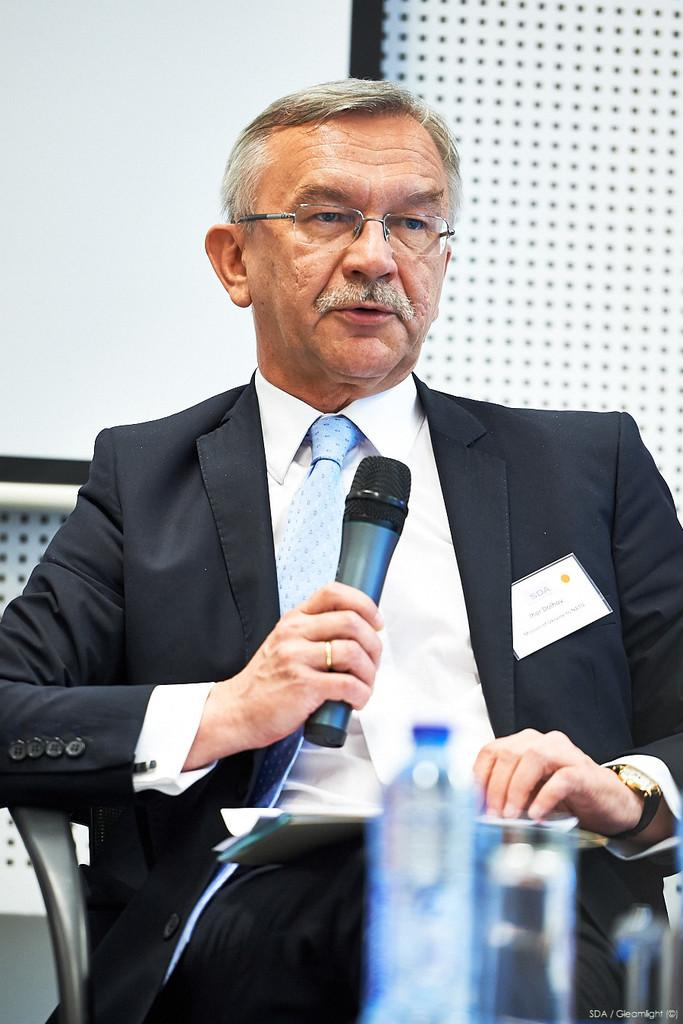What is the man in the image doing? The man is sitting on a chair in the image. What object is the man holding? The man is holding a microphone. Can you describe any accessories the man is wearing? The man is wearing a watch. What items are in front of the man? There is a water bottle and a glass of water in front of the man. What can be seen in the background of the image? There is a wall visible in the background. What is the distribution of the house in the image? There is no house present in the image; it only features a man sitting on a chair. 